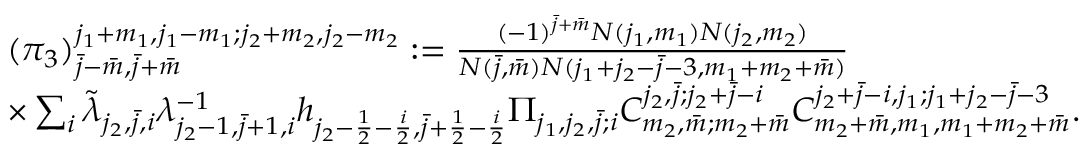Convert formula to latex. <formula><loc_0><loc_0><loc_500><loc_500>\begin{array} { r l } & { ( \pi _ { 3 } ) _ { \bar { j } - \bar { m } , \bar { j } + \bar { m } } ^ { j _ { 1 } + m _ { 1 } , j _ { 1 } - m _ { 1 } ; j _ { 2 } + m _ { 2 } , j _ { 2 } - m _ { 2 } } \colon = \frac { ( - 1 ) ^ { \bar { j } + \bar { m } } N ( j _ { 1 } , m _ { 1 } ) N ( j _ { 2 } , m _ { 2 } ) } { N ( \bar { j } , \bar { m } ) N ( j _ { 1 } + j _ { 2 } - \bar { j } - 3 , m _ { 1 } + m _ { 2 } + \bar { m } ) } } \\ & { \times \sum _ { i } \tilde { \lambda } _ { j _ { 2 } , \bar { j } , i } \lambda _ { j _ { 2 } - 1 , \bar { j } + 1 , i } ^ { - 1 } h _ { j _ { 2 } - \frac { 1 } { 2 } - \frac { i } { 2 } , \bar { j } + \frac { 1 } { 2 } - \frac { i } { 2 } } \Pi _ { j _ { 1 } , j _ { 2 } , \bar { j } ; i } C _ { m _ { 2 } , \bar { m } ; m _ { 2 } + \bar { m } } ^ { j _ { 2 } , \bar { j } ; j _ { 2 } + \bar { j } - i } C _ { m _ { 2 } + \bar { m } , m _ { 1 } , m _ { 1 } + m _ { 2 } + \bar { m } } ^ { j _ { 2 } + \bar { j } - i , j _ { 1 } ; j _ { 1 } + j _ { 2 } - \bar { j } - 3 } . } \end{array}</formula> 